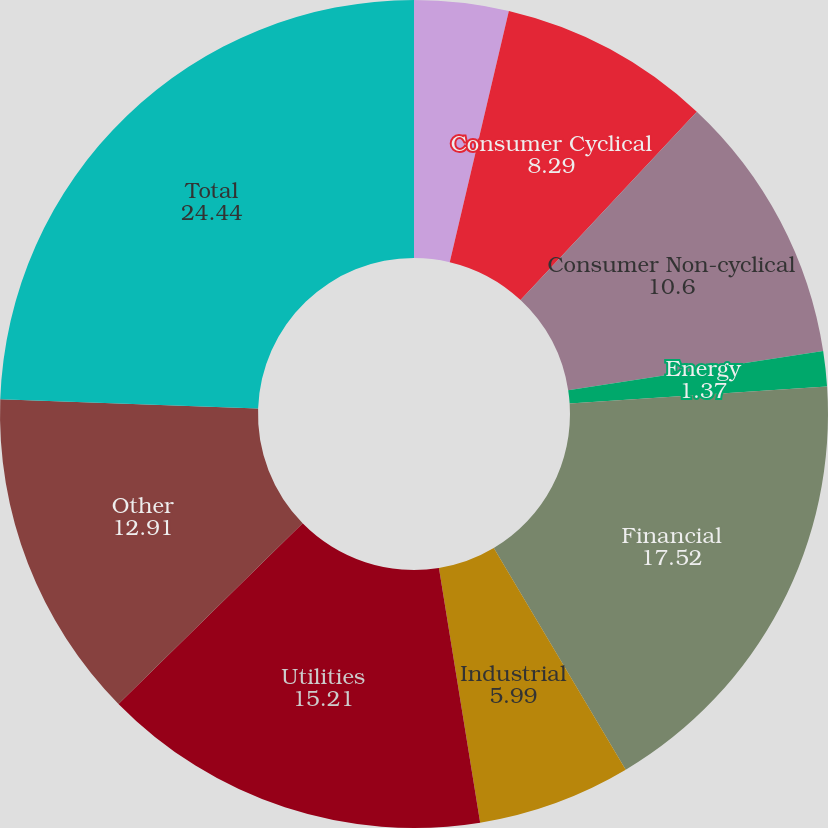Convert chart. <chart><loc_0><loc_0><loc_500><loc_500><pie_chart><fcel>Communications<fcel>Consumer Cyclical<fcel>Consumer Non-cyclical<fcel>Energy<fcel>Financial<fcel>Industrial<fcel>Utilities<fcel>Other<fcel>Total<nl><fcel>3.68%<fcel>8.29%<fcel>10.6%<fcel>1.37%<fcel>17.52%<fcel>5.99%<fcel>15.21%<fcel>12.91%<fcel>24.44%<nl></chart> 